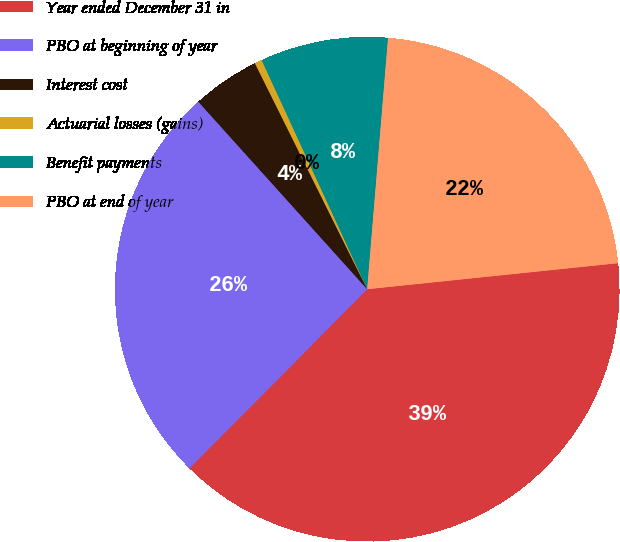<chart> <loc_0><loc_0><loc_500><loc_500><pie_chart><fcel>Year ended December 31 in<fcel>PBO at beginning of year<fcel>Interest cost<fcel>Actuarial losses (gains)<fcel>Benefit payments<fcel>PBO at end of year<nl><fcel>39.09%<fcel>25.9%<fcel>4.33%<fcel>0.47%<fcel>8.19%<fcel>22.04%<nl></chart> 